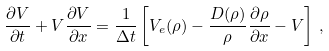<formula> <loc_0><loc_0><loc_500><loc_500>\frac { \partial V } { \partial t } + V \frac { \partial V } { \partial x } = \frac { 1 } { \Delta t } \left [ V _ { e } ( \rho ) - \frac { D ( \rho ) } { \rho } \frac { \partial \rho } { \partial x } - V \right ] \, ,</formula> 